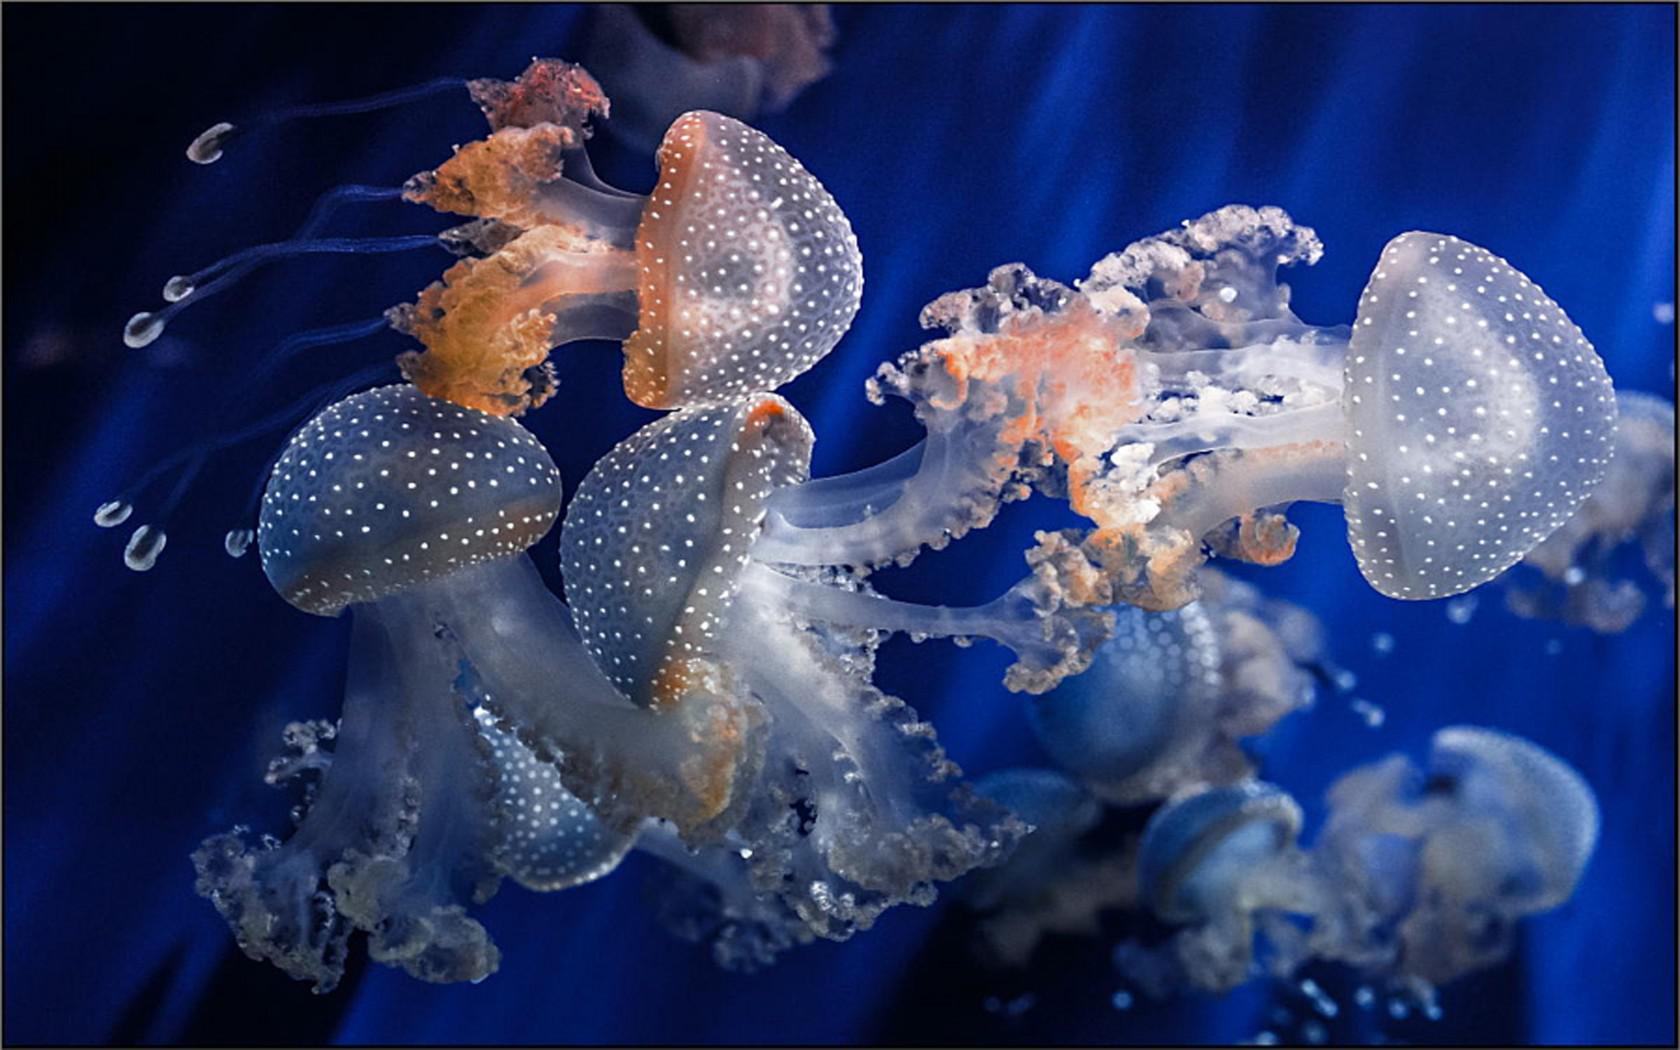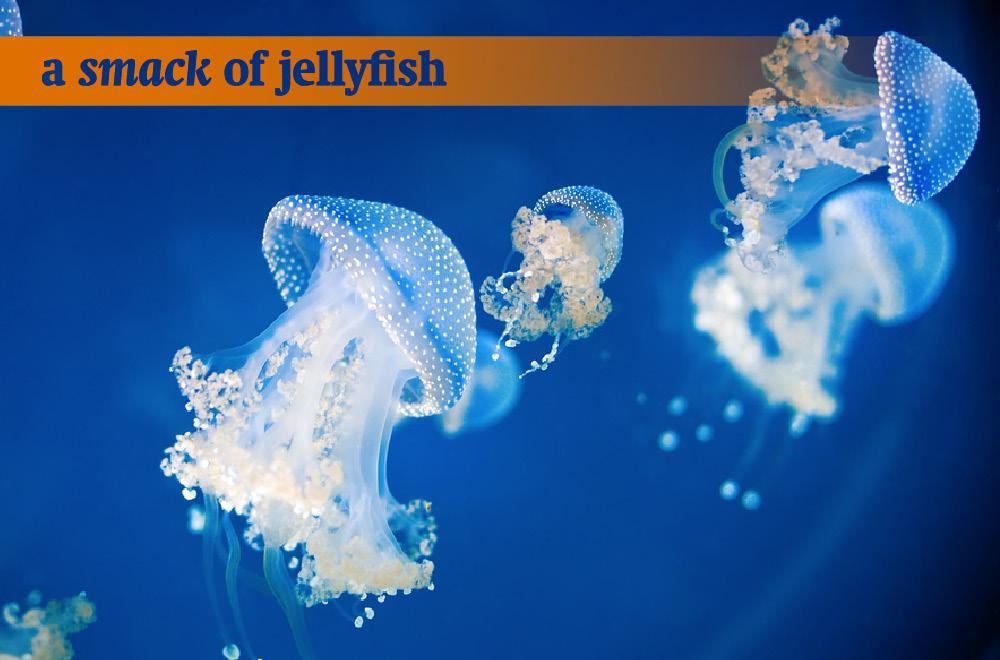The first image is the image on the left, the second image is the image on the right. Assess this claim about the two images: "An image shows at least a dozen vivid orange-red jellyfish.". Correct or not? Answer yes or no. No. 